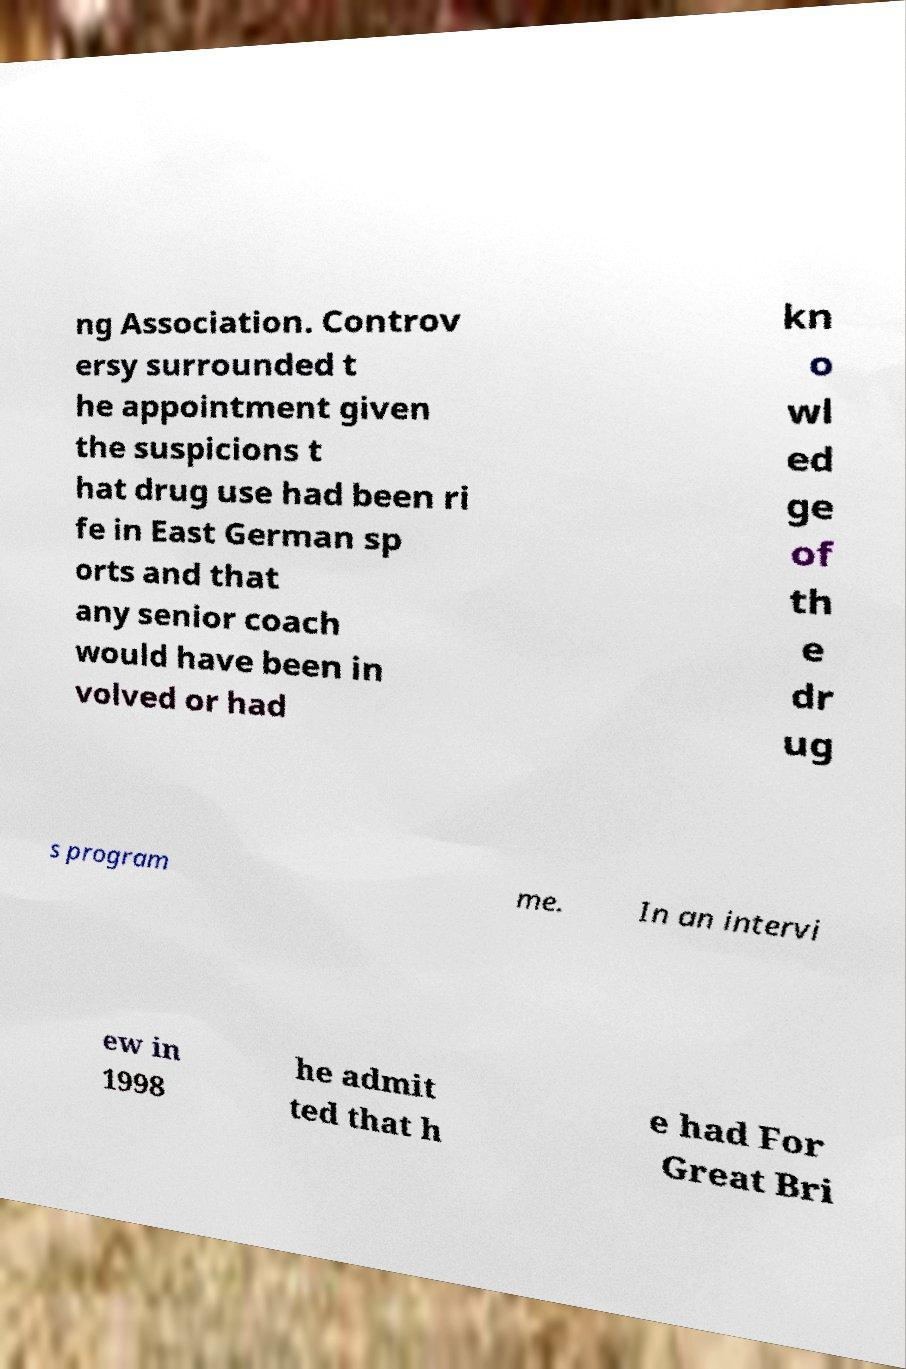Please identify and transcribe the text found in this image. ng Association. Controv ersy surrounded t he appointment given the suspicions t hat drug use had been ri fe in East German sp orts and that any senior coach would have been in volved or had kn o wl ed ge of th e dr ug s program me. In an intervi ew in 1998 he admit ted that h e had For Great Bri 